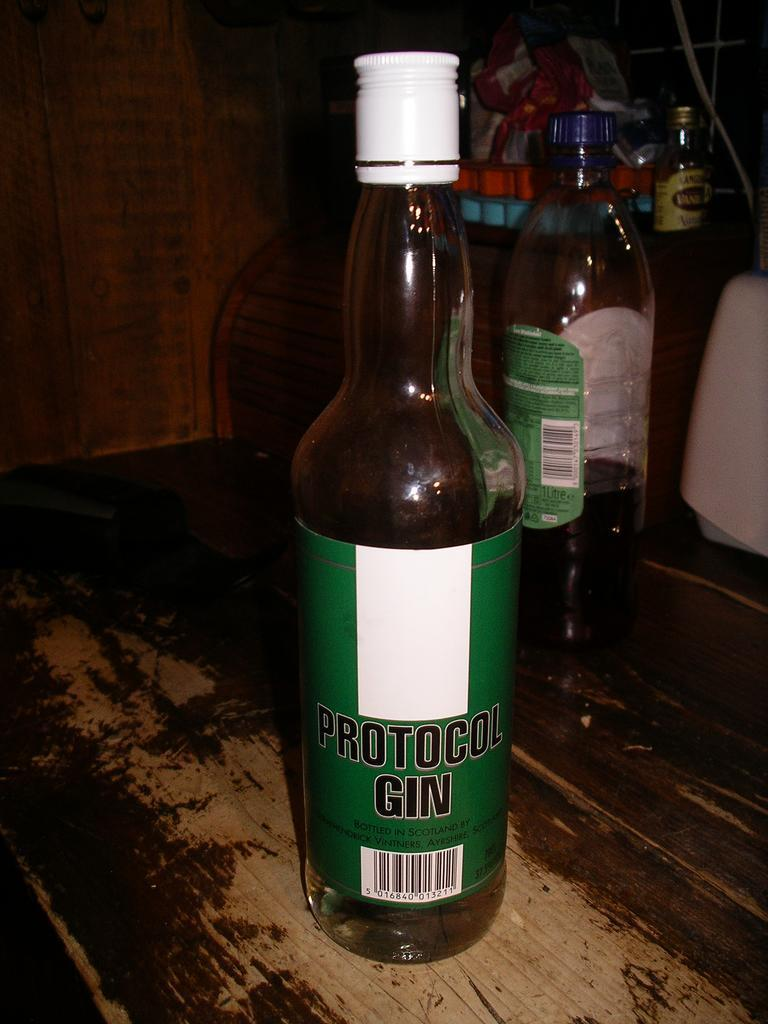<image>
Render a clear and concise summary of the photo. A bottle of Protocol Gin on a weathered wooden tabletop. 